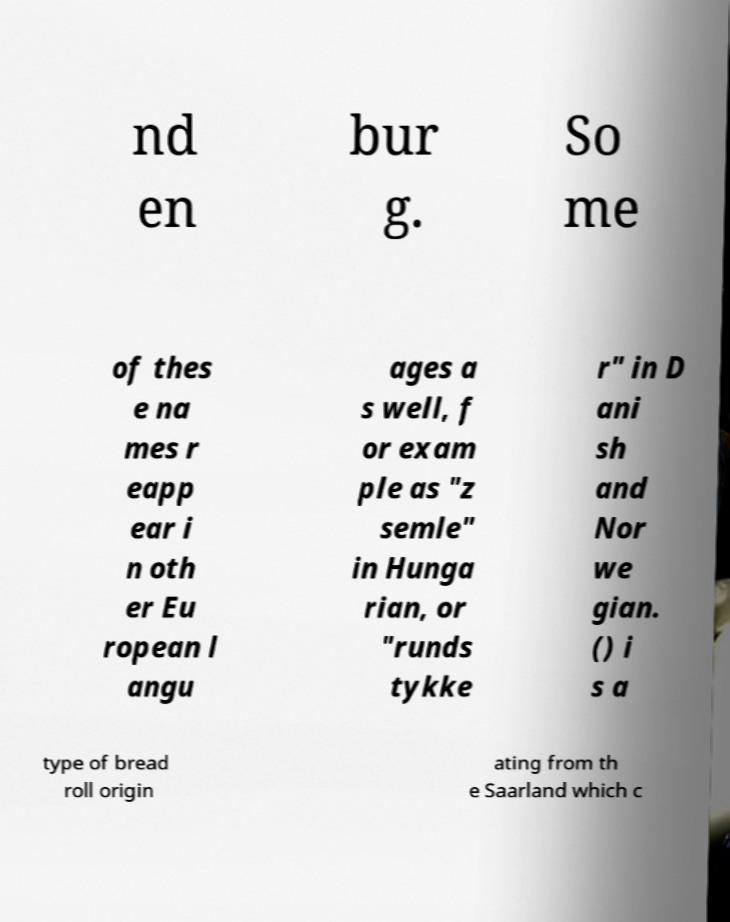I need the written content from this picture converted into text. Can you do that? nd en bur g. So me of thes e na mes r eapp ear i n oth er Eu ropean l angu ages a s well, f or exam ple as "z semle" in Hunga rian, or "runds tykke r" in D ani sh and Nor we gian. () i s a type of bread roll origin ating from th e Saarland which c 